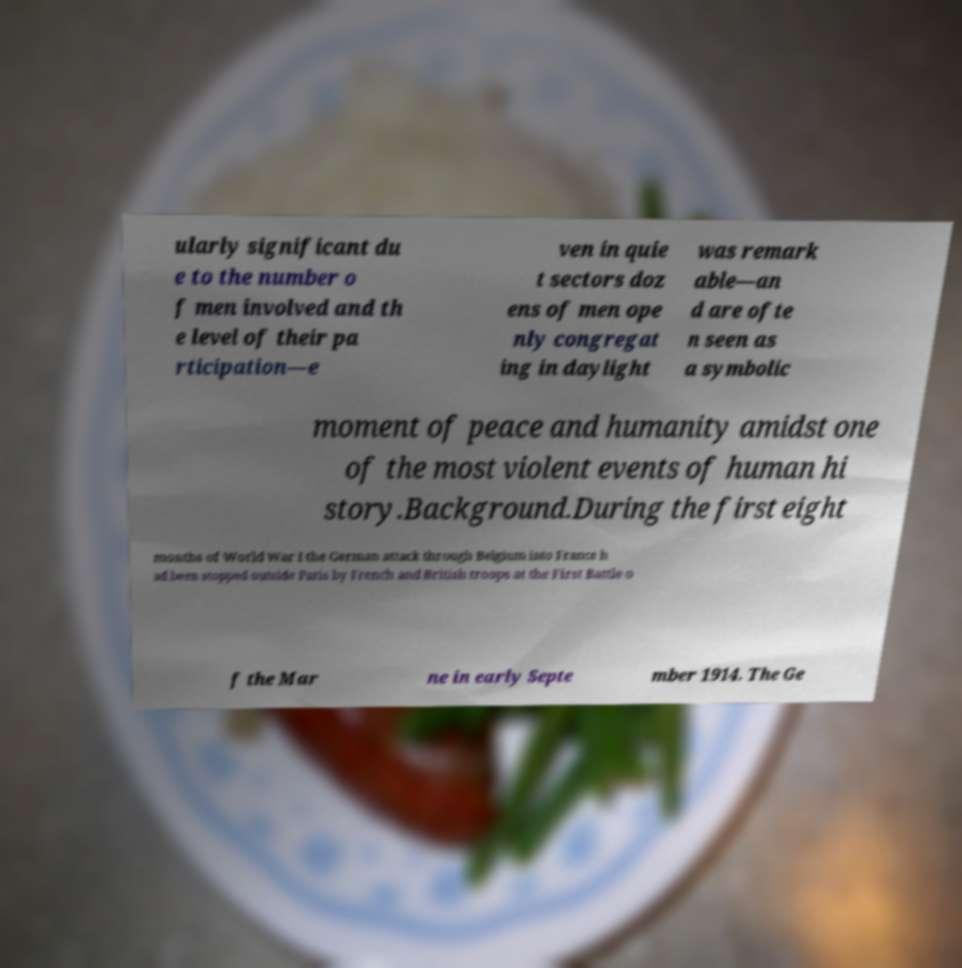What messages or text are displayed in this image? I need them in a readable, typed format. ularly significant du e to the number o f men involved and th e level of their pa rticipation—e ven in quie t sectors doz ens of men ope nly congregat ing in daylight was remark able—an d are ofte n seen as a symbolic moment of peace and humanity amidst one of the most violent events of human hi story.Background.During the first eight months of World War I the German attack through Belgium into France h ad been stopped outside Paris by French and British troops at the First Battle o f the Mar ne in early Septe mber 1914. The Ge 